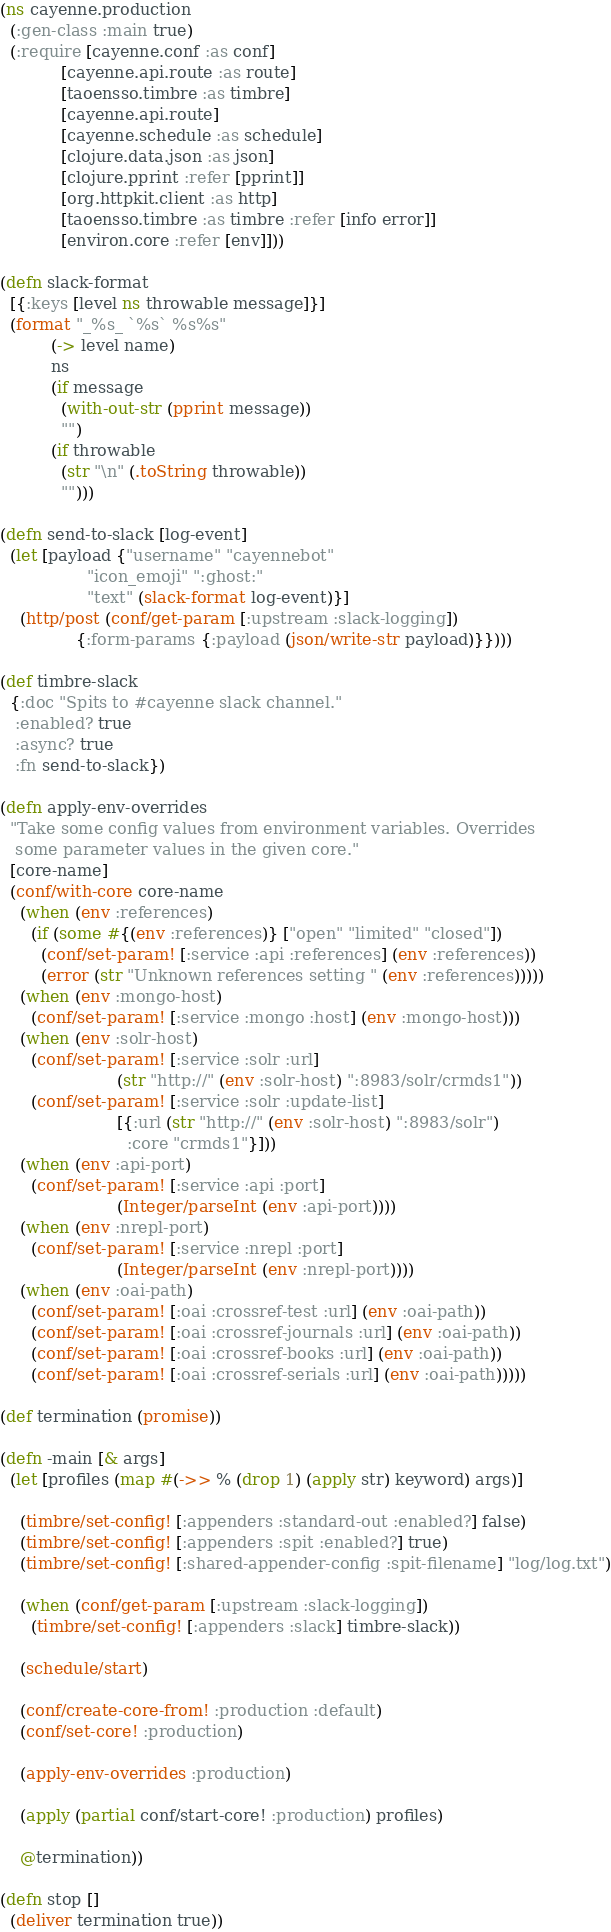Convert code to text. <code><loc_0><loc_0><loc_500><loc_500><_Clojure_>(ns cayenne.production
  (:gen-class :main true)
  (:require [cayenne.conf :as conf]
            [cayenne.api.route :as route]
            [taoensso.timbre :as timbre]
            [cayenne.api.route]
            [cayenne.schedule :as schedule]
            [clojure.data.json :as json]
            [clojure.pprint :refer [pprint]]
            [org.httpkit.client :as http]
            [taoensso.timbre :as timbre :refer [info error]]
            [environ.core :refer [env]]))

(defn slack-format
  [{:keys [level ns throwable message]}]
  (format "_%s_ `%s` %s%s"
          (-> level name)
          ns
          (if message
            (with-out-str (pprint message))
            "")
          (if throwable
            (str "\n" (.toString throwable))
            "")))

(defn send-to-slack [log-event]
  (let [payload {"username" "cayennebot"
                 "icon_emoji" ":ghost:"
                 "text" (slack-format log-event)}]
    (http/post (conf/get-param [:upstream :slack-logging])
               {:form-params {:payload (json/write-str payload)}})))

(def timbre-slack
  {:doc "Spits to #cayenne slack channel."
   :enabled? true
   :async? true
   :fn send-to-slack})

(defn apply-env-overrides
  "Take some config values from environment variables. Overrides
   some parameter values in the given core."
  [core-name]
  (conf/with-core core-name
    (when (env :references)
      (if (some #{(env :references)} ["open" "limited" "closed"])
        (conf/set-param! [:service :api :references] (env :references))
        (error (str "Unknown references setting " (env :references)))))
    (when (env :mongo-host)
      (conf/set-param! [:service :mongo :host] (env :mongo-host)))
    (when (env :solr-host)
      (conf/set-param! [:service :solr :url]
                       (str "http://" (env :solr-host) ":8983/solr/crmds1"))
      (conf/set-param! [:service :solr :update-list]
                       [{:url (str "http://" (env :solr-host) ":8983/solr")
                         :core "crmds1"}]))
    (when (env :api-port)
      (conf/set-param! [:service :api :port]
                       (Integer/parseInt (env :api-port))))
    (when (env :nrepl-port)
      (conf/set-param! [:service :nrepl :port]
                       (Integer/parseInt (env :nrepl-port))))
    (when (env :oai-path)
      (conf/set-param! [:oai :crossref-test :url] (env :oai-path))
      (conf/set-param! [:oai :crossref-journals :url] (env :oai-path))
      (conf/set-param! [:oai :crossref-books :url] (env :oai-path))
      (conf/set-param! [:oai :crossref-serials :url] (env :oai-path)))))

(def termination (promise))

(defn -main [& args]
  (let [profiles (map #(->> % (drop 1) (apply str) keyword) args)]

    (timbre/set-config! [:appenders :standard-out :enabled?] false)
    (timbre/set-config! [:appenders :spit :enabled?] true)
    (timbre/set-config! [:shared-appender-config :spit-filename] "log/log.txt")

    (when (conf/get-param [:upstream :slack-logging])
      (timbre/set-config! [:appenders :slack] timbre-slack))

    (schedule/start)
    
    (conf/create-core-from! :production :default)
    (conf/set-core! :production)

    (apply-env-overrides :production)
    
    (apply (partial conf/start-core! :production) profiles)
    
    @termination))
  
(defn stop []
  (deliver termination true))
</code> 